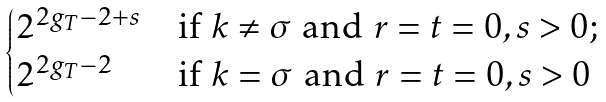<formula> <loc_0><loc_0><loc_500><loc_500>\begin{cases} 2 ^ { 2 g _ { T } - 2 + s } & \text {if } k \neq \sigma \text { and } r = t = 0 , s > 0 ; \\ 2 ^ { 2 g _ { T } - 2 } & \text {if } k = \sigma \text { and } r = t = 0 , s > 0 \\ \end{cases}</formula> 